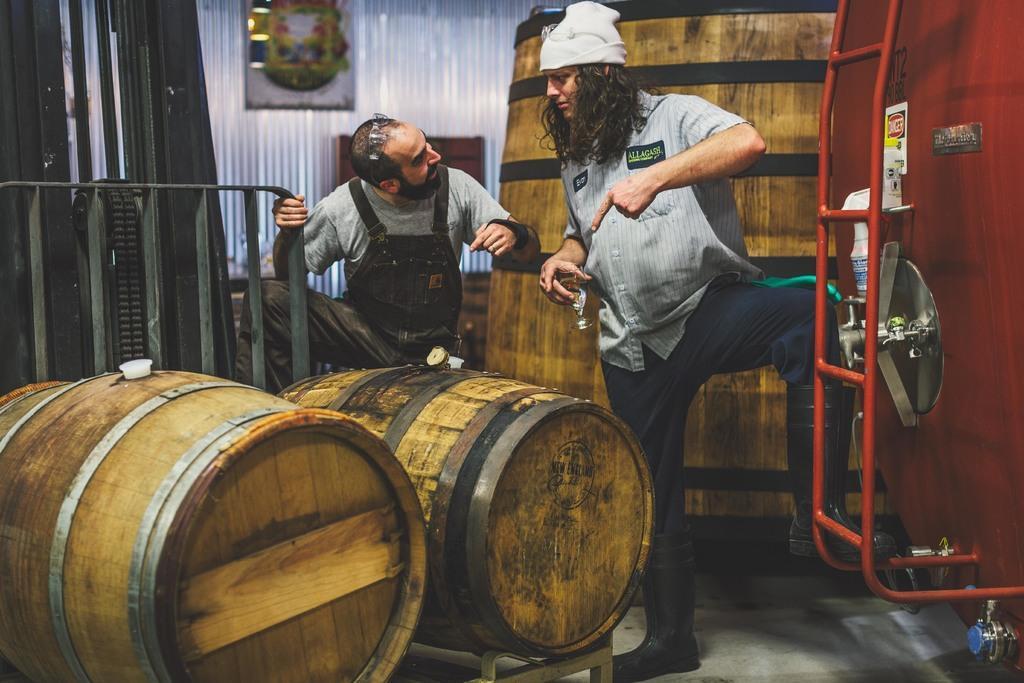Could you give a brief overview of what you see in this image? In this image we can see few persons. There are few barrels in the image. There is an object at the right side of the image and few objects on it. There are few curtains in the image. 